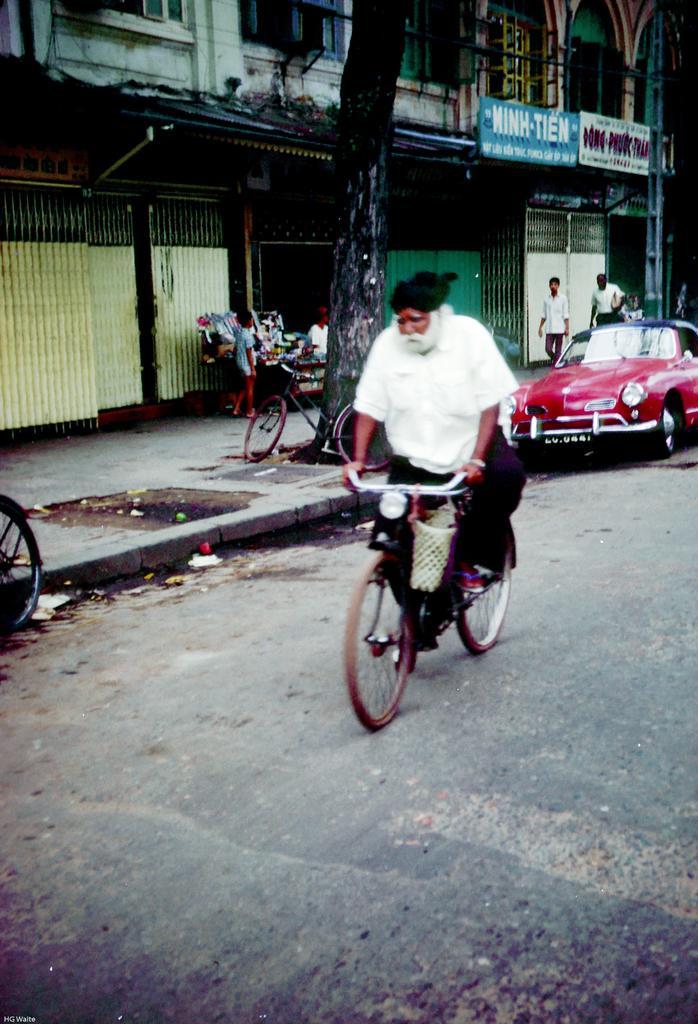Describe this image in one or two sentences. A man wearing a white shirt and turban is riding a cycle on a road. There is a car parked on the side of the road. On the sidewalk there is a cycle, tree, and two persons are walking. And there are some buildings near to the sidewalks. 